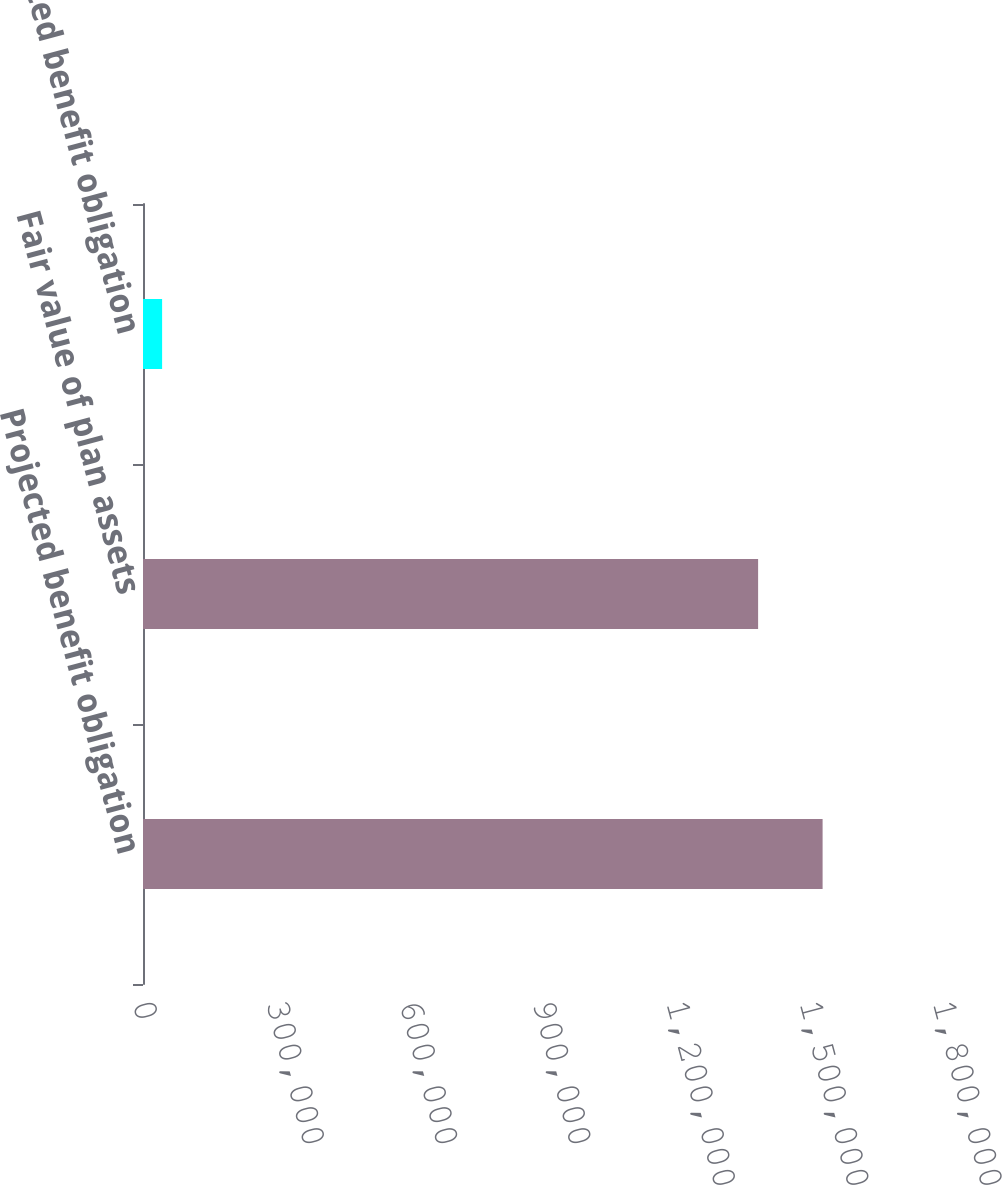<chart> <loc_0><loc_0><loc_500><loc_500><bar_chart><fcel>Projected benefit obligation<fcel>Fair value of plan assets<fcel>Accumulated benefit obligation<nl><fcel>1.5291e+06<fcel>1.384e+06<fcel>43000<nl></chart> 